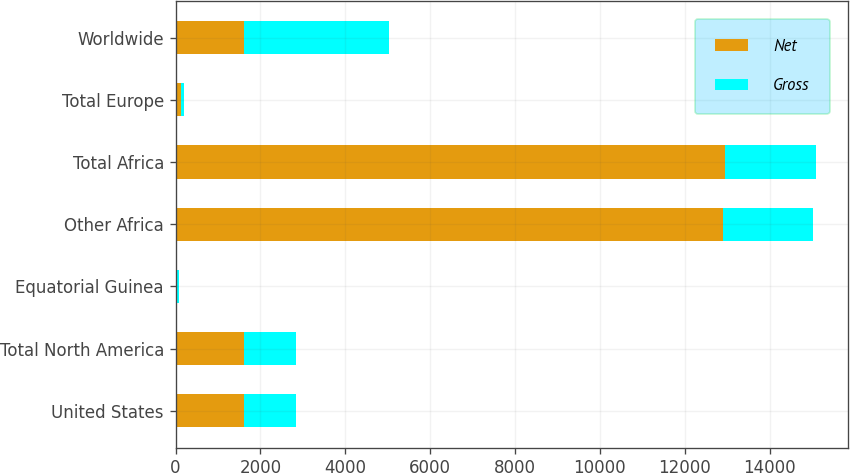Convert chart to OTSL. <chart><loc_0><loc_0><loc_500><loc_500><stacked_bar_chart><ecel><fcel>United States<fcel>Total North America<fcel>Equatorial Guinea<fcel>Other Africa<fcel>Total Africa<fcel>Total Europe<fcel>Worldwide<nl><fcel>Net<fcel>1620<fcel>1620<fcel>45<fcel>12909<fcel>12954<fcel>131<fcel>1620<nl><fcel>Gross<fcel>1215<fcel>1215<fcel>29<fcel>2108<fcel>2137<fcel>68<fcel>3420<nl></chart> 